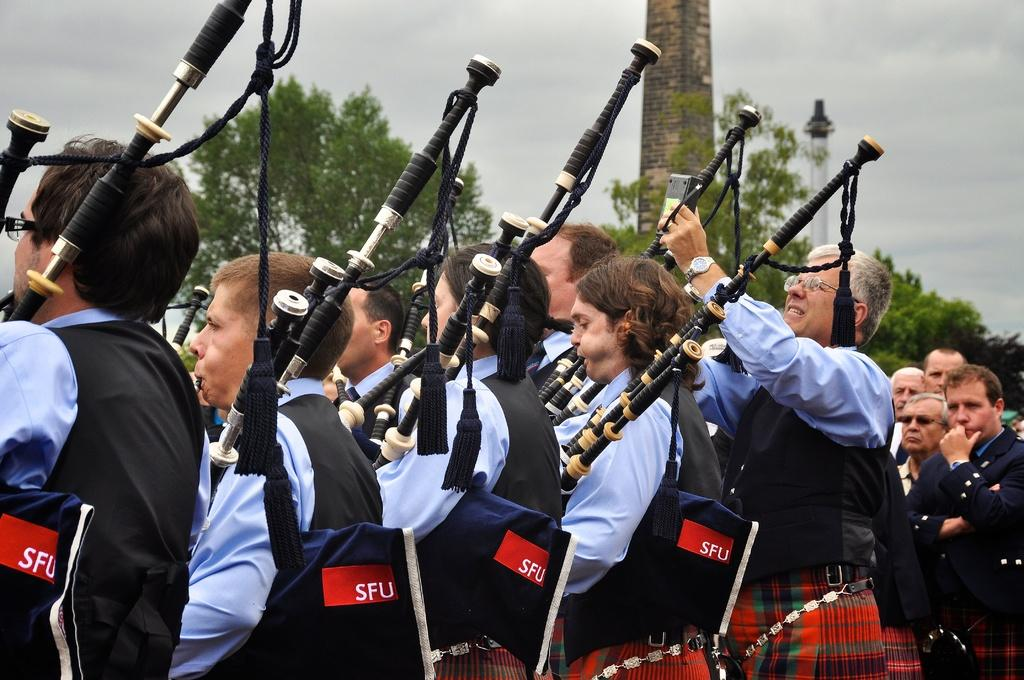How many people are in the image? There are people in the image, but the exact number is not specified. What are the people wearing? The people are wearing the same dress. What are the people doing in the image? The people are playing musical instruments. What can be seen in the background of the image? There are trees visible in the image. Are there any other people around the main group? Yes, there are other people around the main group. How many chickens are there in the image? There is no mention of chickens in the image, so we cannot determine their number. Is there a gate visible in the image? There is no mention of a gate in the image, so we cannot determine its presence. 